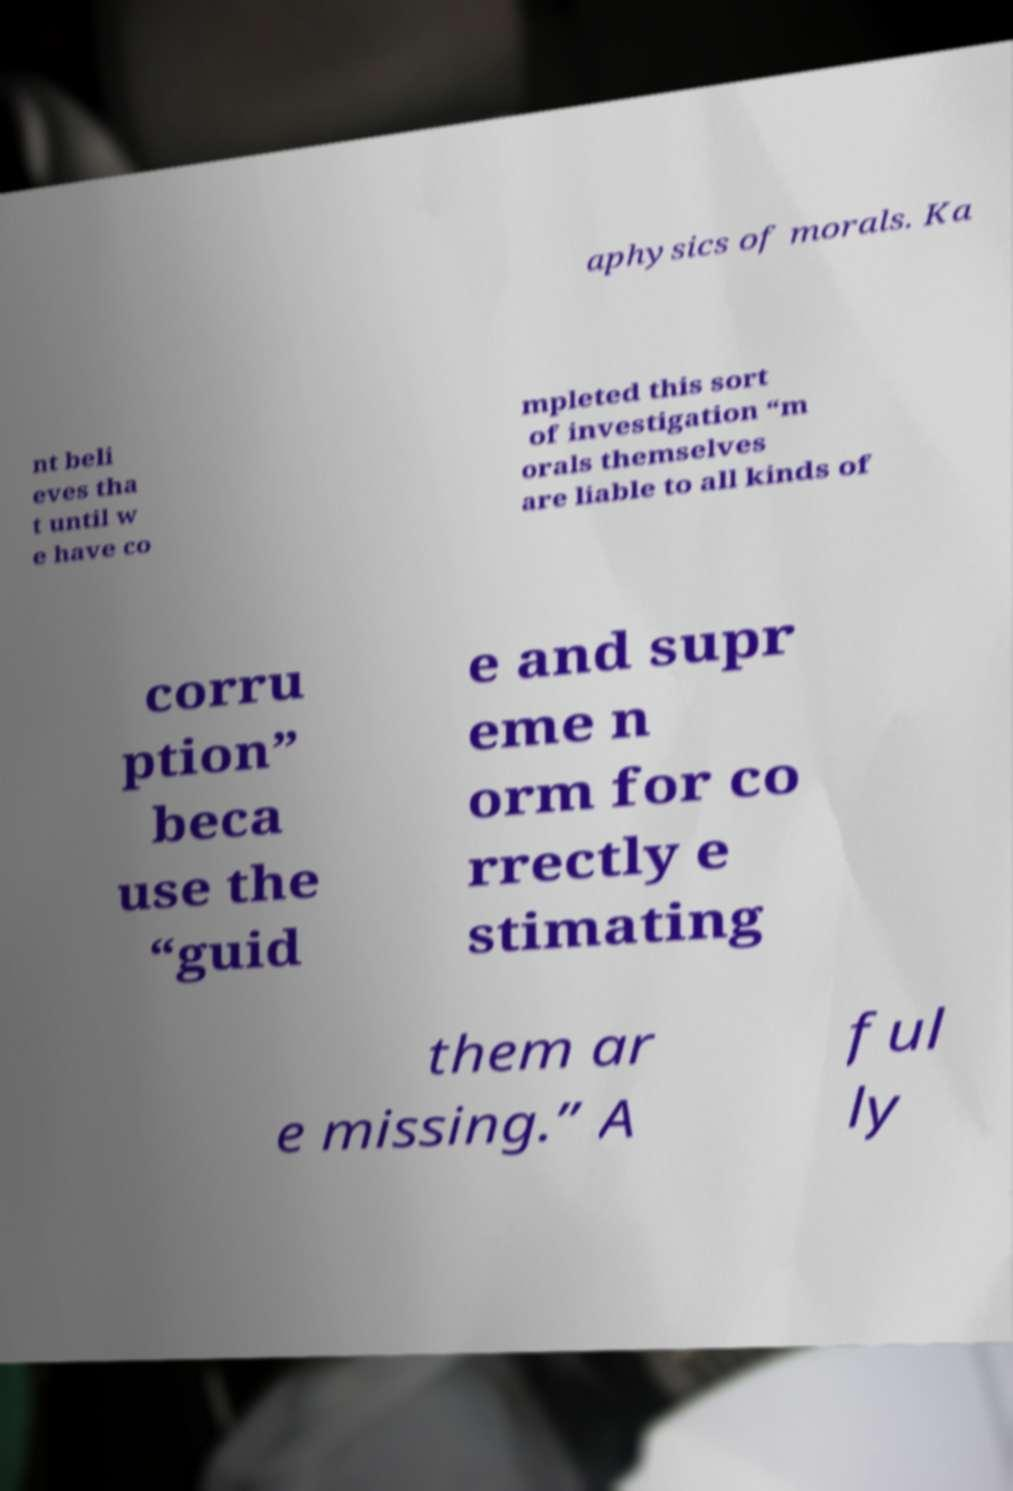Could you assist in decoding the text presented in this image and type it out clearly? aphysics of morals. Ka nt beli eves tha t until w e have co mpleted this sort of investigation “m orals themselves are liable to all kinds of corru ption” beca use the “guid e and supr eme n orm for co rrectly e stimating them ar e missing.” A ful ly 